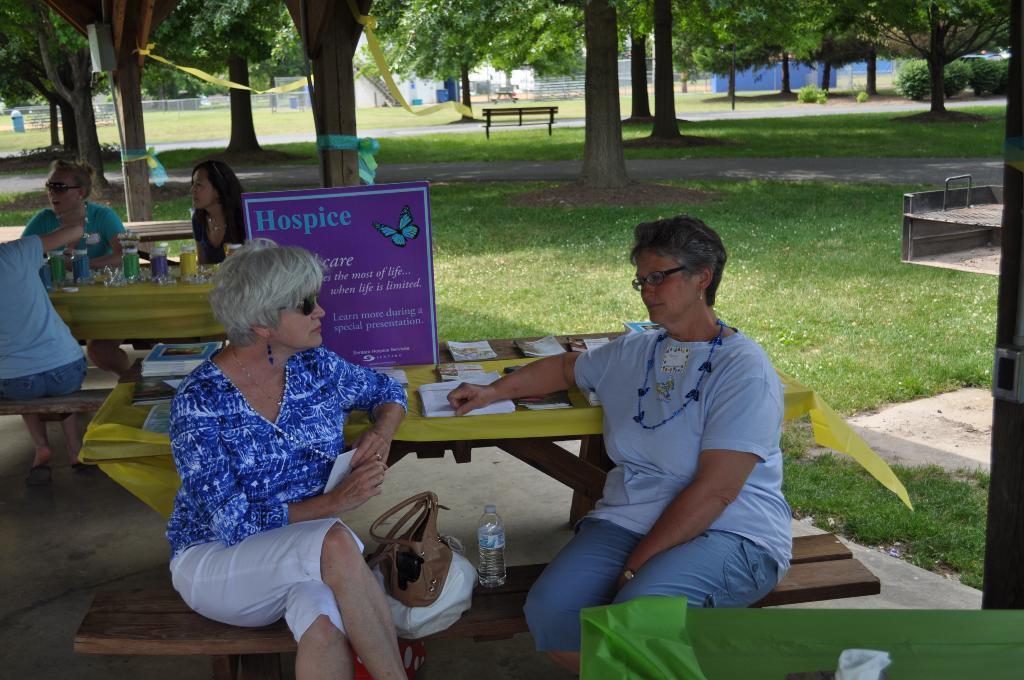Could you give a brief overview of what you see in this image? In this picture we can see two woman sitting on the table, in the background we can see another two women sitting on the table, we can see grass in the bottom, and there is a table also we can see number of trees in the background and a dustbin here. 